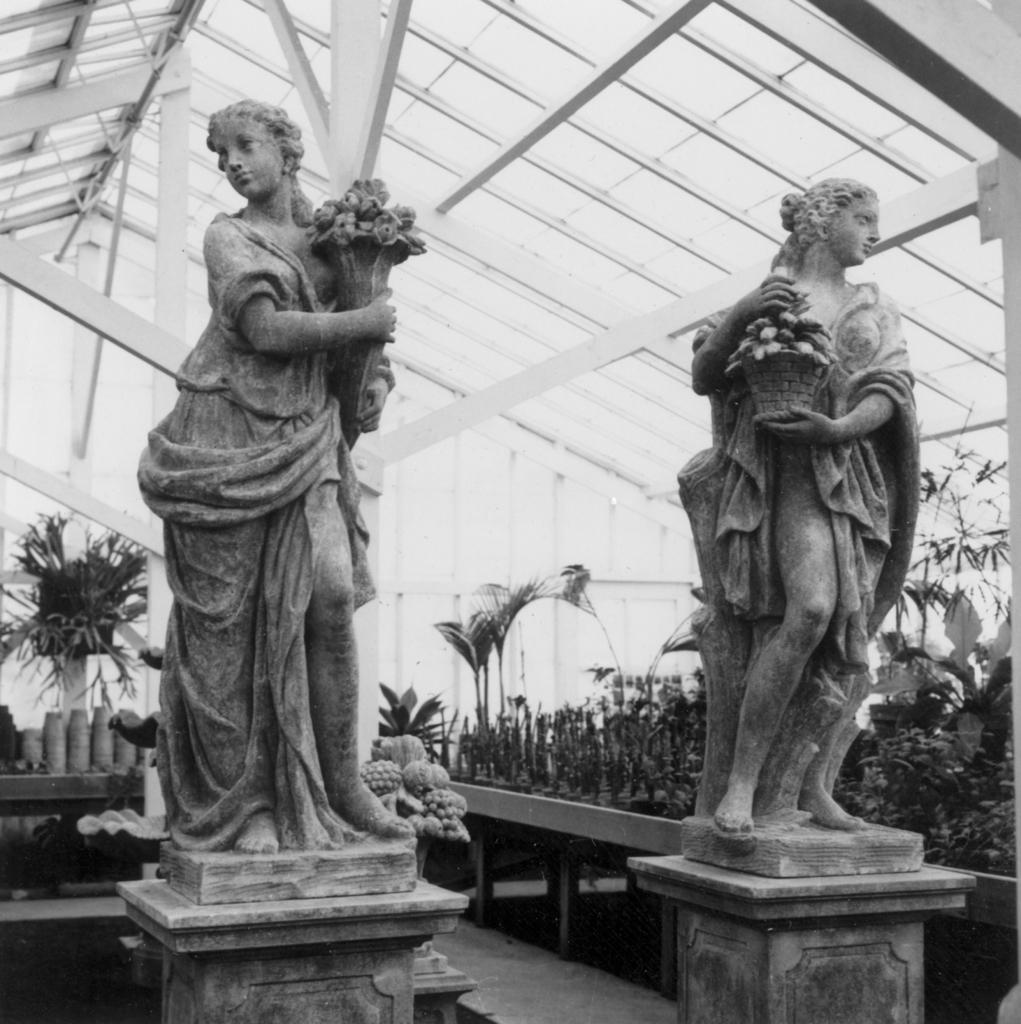What is depicted in the image involving two persons? There are two sculptures of two persons in the image. What are the sculptures holding? The sculptures are holding plants. What can be seen in the background of the image? There are plants and pots on tables in the background of the image. What type of loaf can be seen in the hands of the sculptures? There is no loaf present in the image; the sculptures are holding plants. Is there any sleet visible in the image? There is no mention of sleet in the image; it features two sculptures holding plants and a background with plants and pots on tables. 